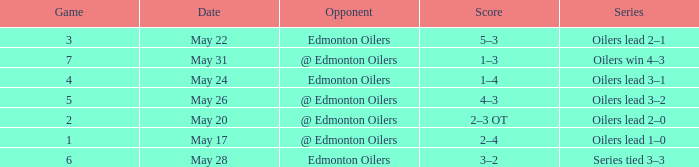What was the score when the opponent of edmonton oilers played a game larger than 1, and the oilers led the series 3-2? 4–3. I'm looking to parse the entire table for insights. Could you assist me with that? {'header': ['Game', 'Date', 'Opponent', 'Score', 'Series'], 'rows': [['3', 'May 22', 'Edmonton Oilers', '5–3', 'Oilers lead 2–1'], ['7', 'May 31', '@ Edmonton Oilers', '1–3', 'Oilers win 4–3'], ['4', 'May 24', 'Edmonton Oilers', '1–4', 'Oilers lead 3–1'], ['5', 'May 26', '@ Edmonton Oilers', '4–3', 'Oilers lead 3–2'], ['2', 'May 20', '@ Edmonton Oilers', '2–3 OT', 'Oilers lead 2–0'], ['1', 'May 17', '@ Edmonton Oilers', '2–4', 'Oilers lead 1–0'], ['6', 'May 28', 'Edmonton Oilers', '3–2', 'Series tied 3–3']]} 